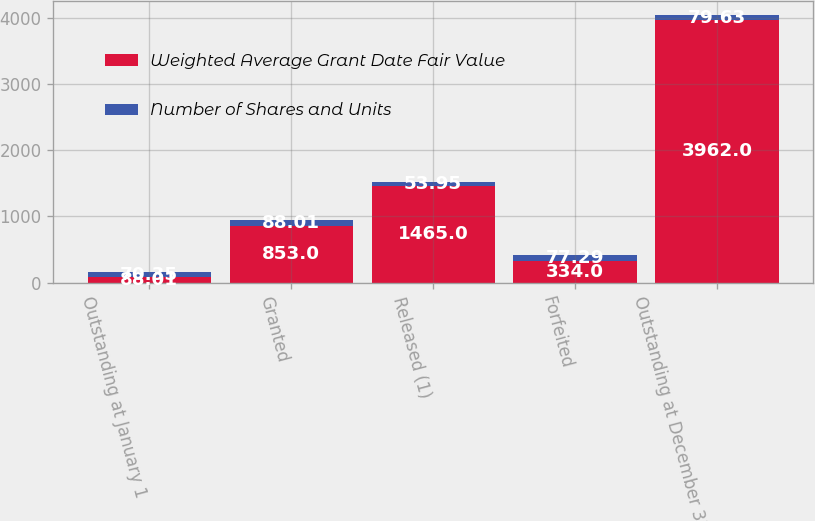<chart> <loc_0><loc_0><loc_500><loc_500><stacked_bar_chart><ecel><fcel>Outstanding at January 1<fcel>Granted<fcel>Released (1)<fcel>Forfeited<fcel>Outstanding at December 31 (2)<nl><fcel>Weighted Average Grant Date Fair Value<fcel>88.01<fcel>853<fcel>1465<fcel>334<fcel>3962<nl><fcel>Number of Shares and Units<fcel>70.35<fcel>88.01<fcel>53.95<fcel>77.29<fcel>79.63<nl></chart> 